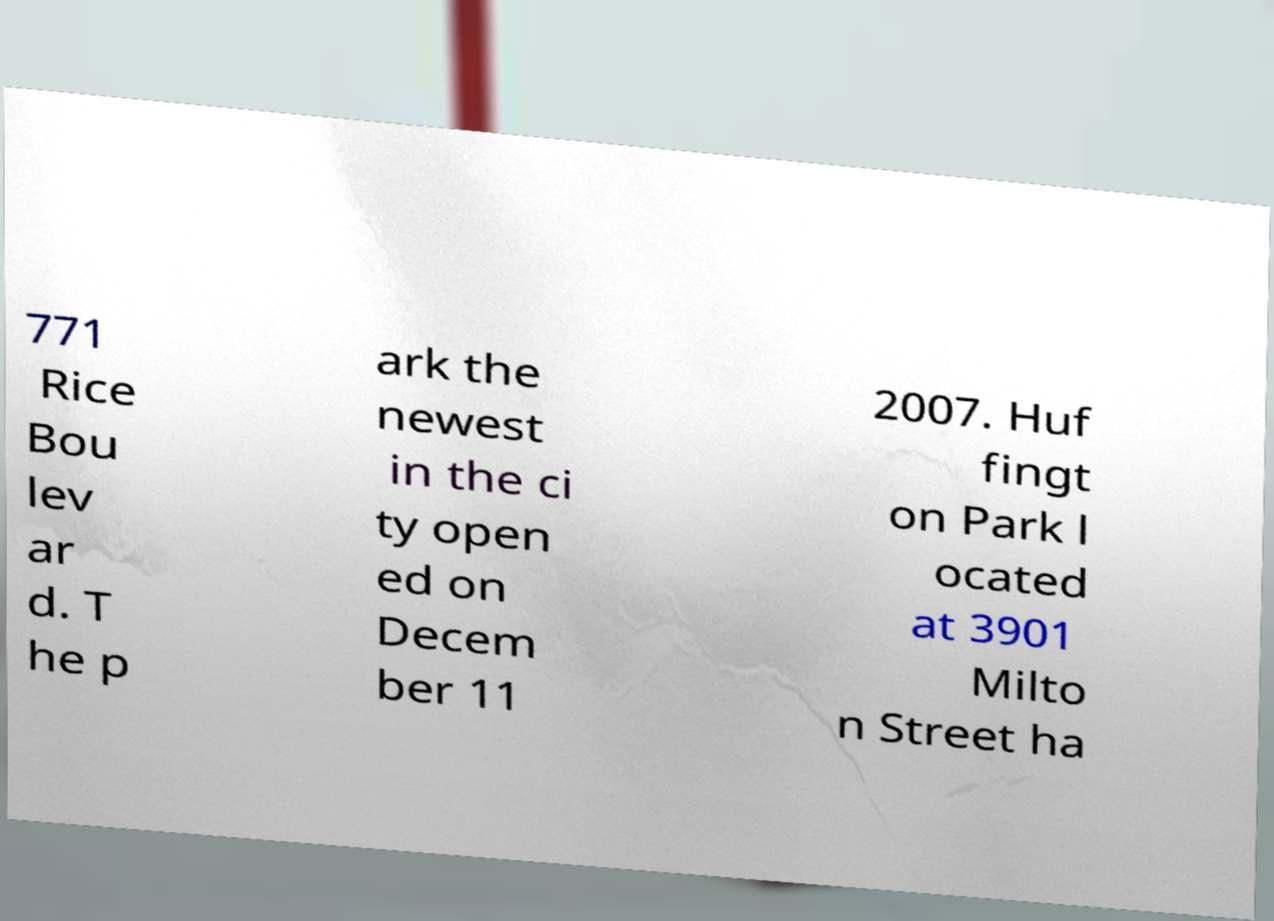I need the written content from this picture converted into text. Can you do that? 771 Rice Bou lev ar d. T he p ark the newest in the ci ty open ed on Decem ber 11 2007. Huf fingt on Park l ocated at 3901 Milto n Street ha 